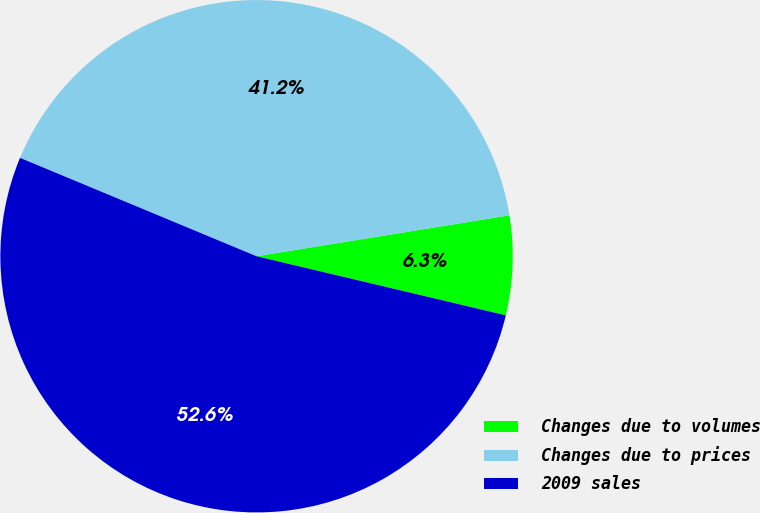Convert chart. <chart><loc_0><loc_0><loc_500><loc_500><pie_chart><fcel>Changes due to volumes<fcel>Changes due to prices<fcel>2009 sales<nl><fcel>6.26%<fcel>41.17%<fcel>52.57%<nl></chart> 